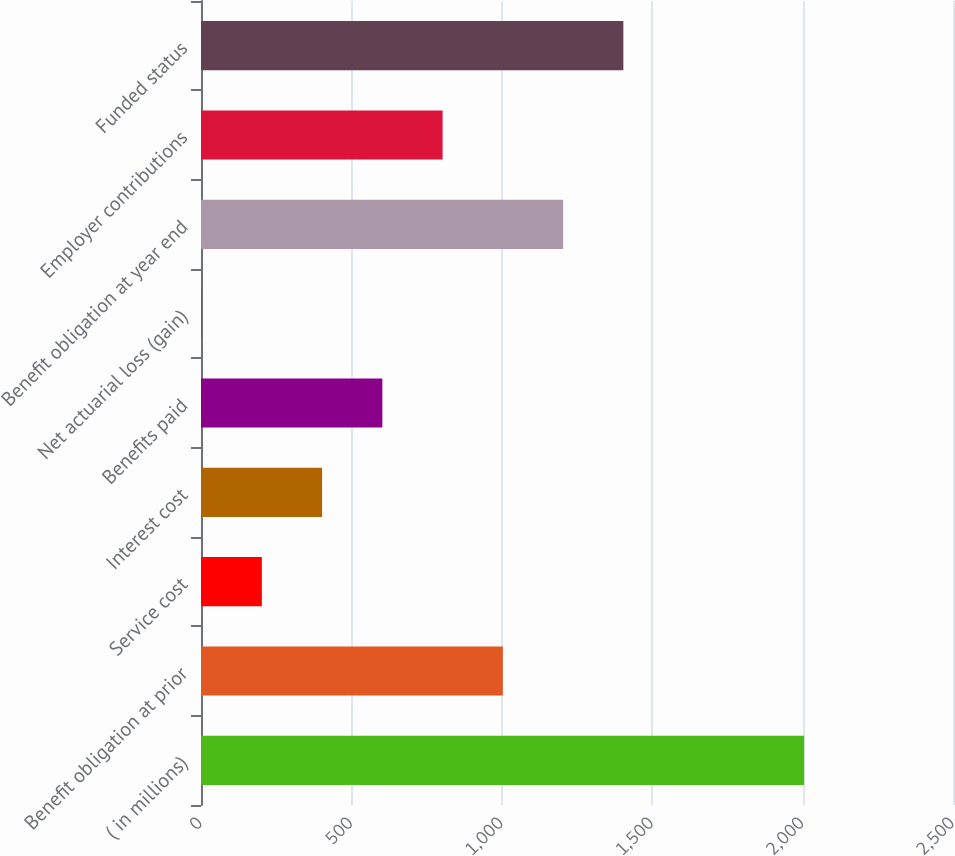Convert chart to OTSL. <chart><loc_0><loc_0><loc_500><loc_500><bar_chart><fcel>( in millions)<fcel>Benefit obligation at prior<fcel>Service cost<fcel>Interest cost<fcel>Benefits paid<fcel>Net actuarial loss (gain)<fcel>Benefit obligation at year end<fcel>Employer contributions<fcel>Funded status<nl><fcel>2005<fcel>1003.5<fcel>202.3<fcel>402.6<fcel>602.9<fcel>2<fcel>1203.8<fcel>803.2<fcel>1404.1<nl></chart> 